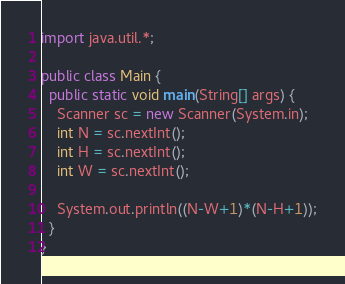<code> <loc_0><loc_0><loc_500><loc_500><_Java_>import java.util.*;

public class Main {
  public static void main(String[] args) {
    Scanner sc = new Scanner(System.in);
    int N = sc.nextInt();
    int H = sc.nextInt();
    int W = sc.nextInt();
    
    System.out.println((N-W+1)*(N-H+1));
  }
}</code> 